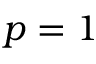<formula> <loc_0><loc_0><loc_500><loc_500>p = 1</formula> 